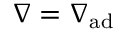Convert formula to latex. <formula><loc_0><loc_0><loc_500><loc_500>{ \nabla } = { \nabla _ { a d } }</formula> 